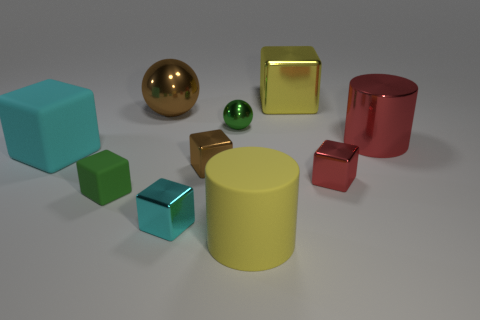Subtract all tiny blocks. How many blocks are left? 2 Subtract all yellow cylinders. How many cylinders are left? 1 Subtract all purple cylinders. How many cyan blocks are left? 2 Subtract all cylinders. How many objects are left? 8 Subtract 1 balls. How many balls are left? 1 Subtract all brown cylinders. Subtract all red spheres. How many cylinders are left? 2 Subtract all large cyan cubes. Subtract all big red objects. How many objects are left? 8 Add 9 small matte things. How many small matte things are left? 10 Add 9 green matte blocks. How many green matte blocks exist? 10 Subtract 0 blue cubes. How many objects are left? 10 